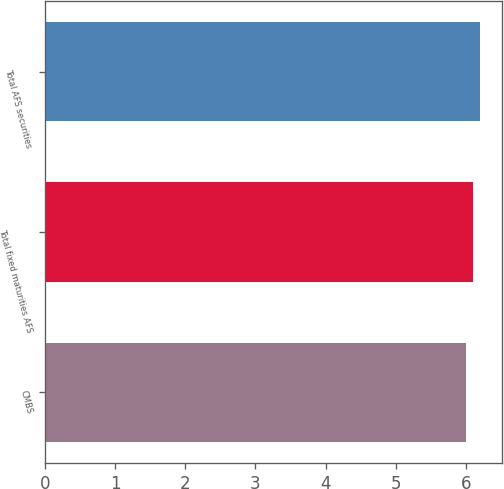Convert chart to OTSL. <chart><loc_0><loc_0><loc_500><loc_500><bar_chart><fcel>CMBS<fcel>Total fixed maturities AFS<fcel>Total AFS securities<nl><fcel>6<fcel>6.1<fcel>6.2<nl></chart> 